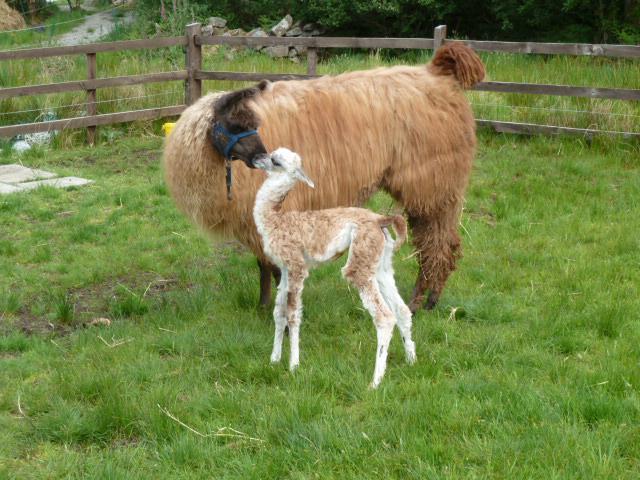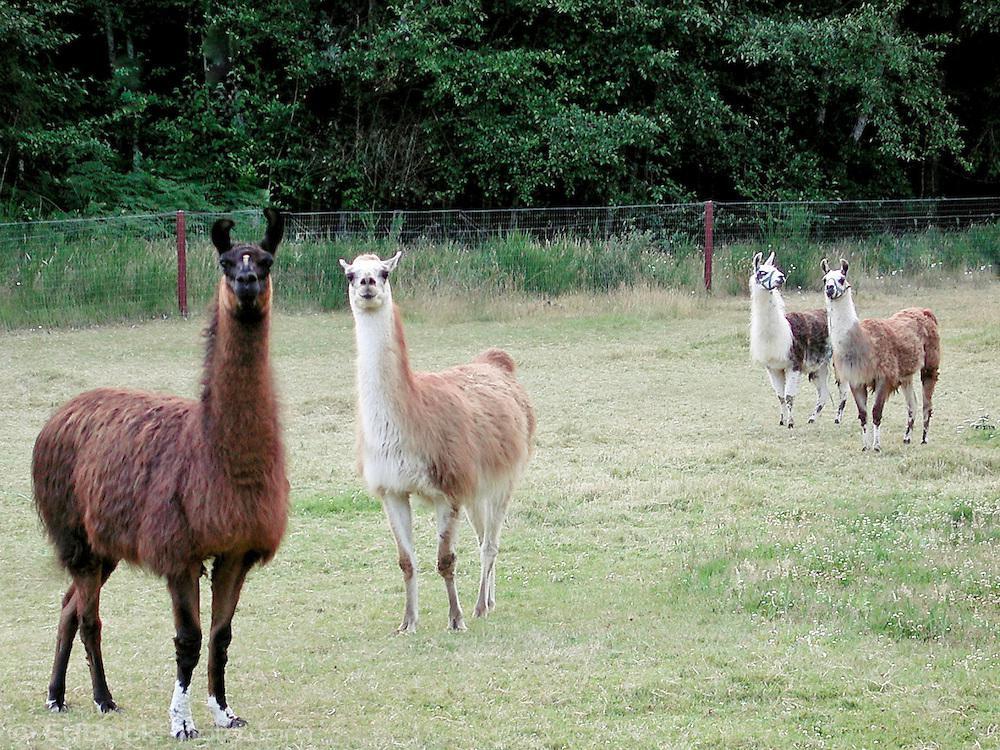The first image is the image on the left, the second image is the image on the right. Assess this claim about the two images: "There is exactly one llama in the left image.". Correct or not? Answer yes or no. No. 